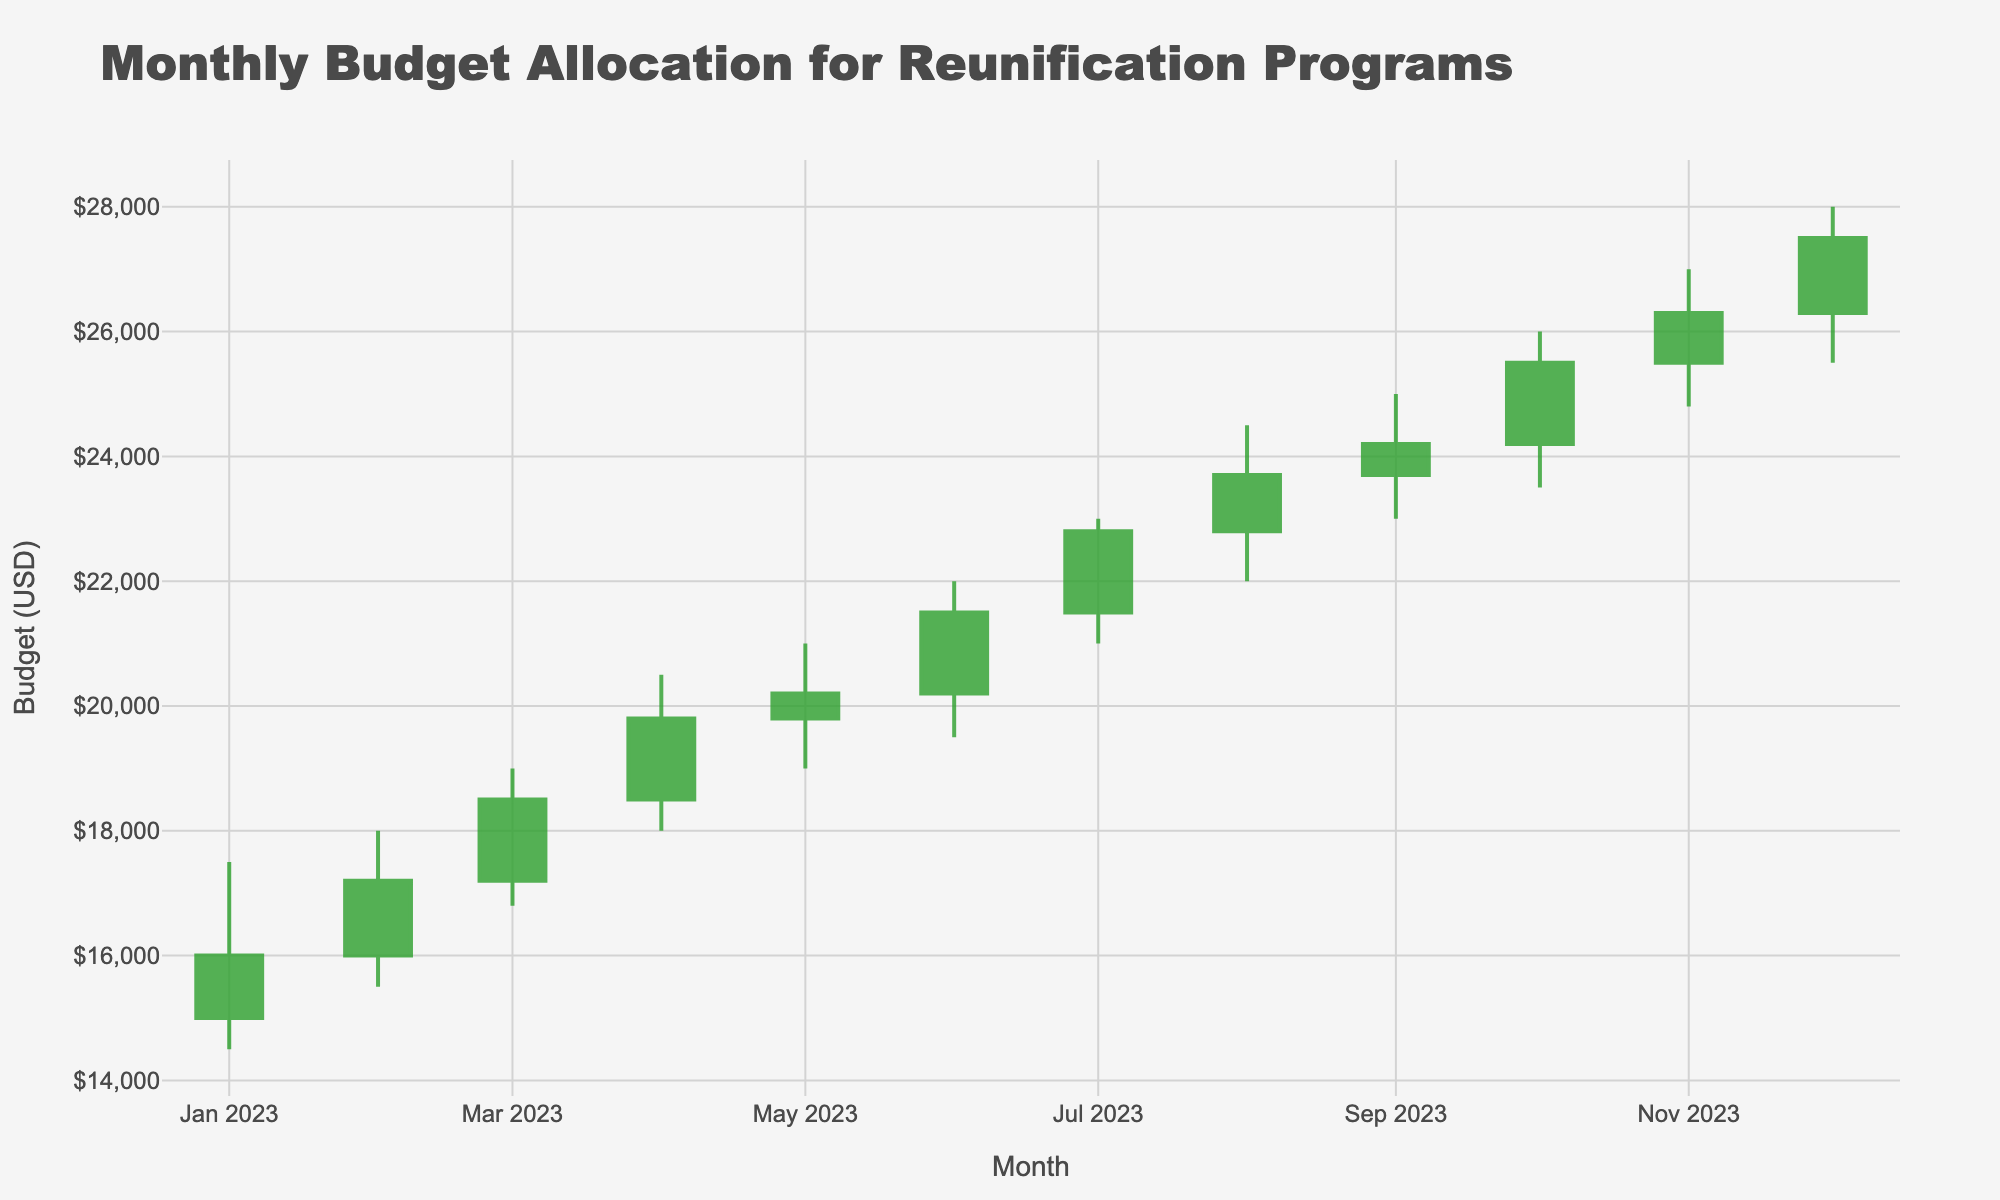What is the title of the figure? The title is displayed at the top of the chart and describes the purpose of the figure. In this case, it is "Monthly Budget Allocation for Reunification Programs".
Answer: Monthly Budget Allocation for Reunification Programs Which month has the highest closing budget? The closing budget is represented by the closing price at the end of each month. By looking at the closing values, the highest closing budget is in December with $27,500.
Answer: December What is the difference between the highest and lowest budget in March? The highest budget in March is $19,000, and the lowest is $16,800. The difference between them is $19,000 - $16,800 = $2,200.
Answer: $2,200 How many times did the monthly budget increase from the opening to the closing? To determine this, check the months where the closing value is higher than the opening value. January (16,000 > 15,000), February (17,200 > 16,000), March (18,500 > 17,200), April (19,800 > 18,500), May (20,200 > 19,800), June (21,500 > 20,200), July (22,800 > 21,500), August (23,700 > 22,800), September (24,200 > 23,700), October (25,500 > 24,200), November (26,300 > 25,500), December (27,500 > 26,300). There are 12 such instances.
Answer: 12 What is the average closing budget for the first quarter of the year? The closing values for January, February, and March are $16,000, $17,200, and $18,500 respectively. The average is calculated as ($16,000 + $17,200 + $18,500) / 3 = $51,700 / 3 = $17,233.33.
Answer: $17,233.33 Which month shows the greatest increase in budget within the month? The increase within a month is determined by the difference between the highest and lowest values. By checking each month, October has the highest difference with the high value being $26,000 and the low value being $23,500, yielding a difference of $2,500.
Answer: October What was the opening budget in July? The opening budget for each month is indicated by the "Open" value. For July, it is $21,500.
Answer: $21,500 What is the overall trend in the monthly budget over the year? Observing the opening and closing values from January to December, there is a consistent upward trend in the budget, with both opening and closing values increasing each month.
Answer: Upward trend How does the closing budget of November compare to August? The closing values for November and August are $26,300 and $23,700, respectively. November has a higher closing budget.
Answer: November is higher 